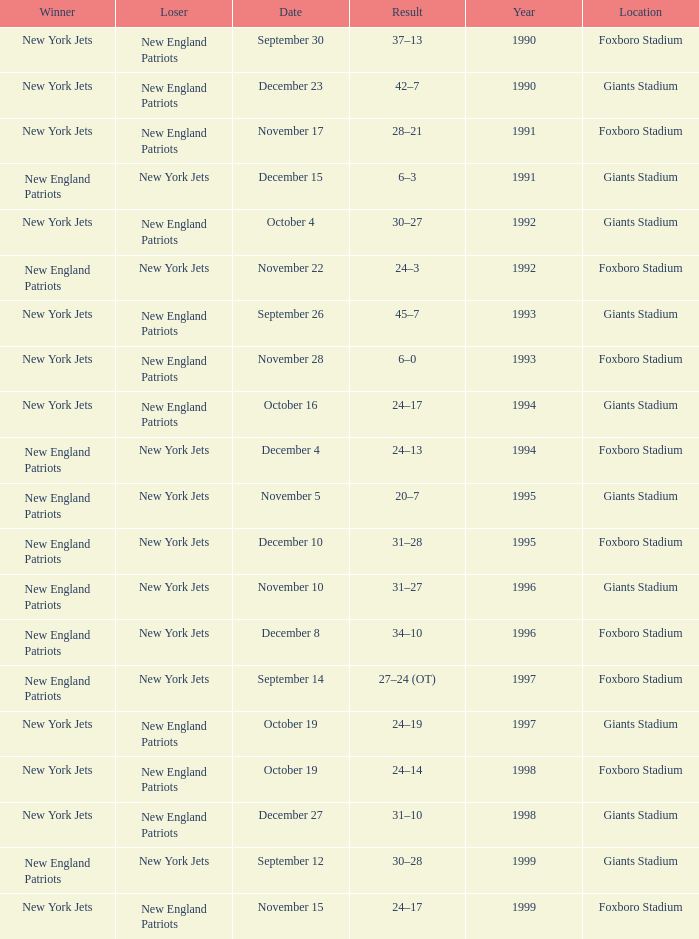What team was the lower when the winner was the new york jets, and a Year earlier than 1994, and a Result of 37–13? New England Patriots. 